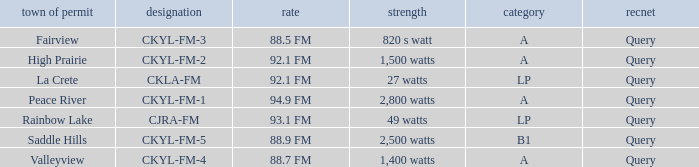Write the full table. {'header': ['town of permit', 'designation', 'rate', 'strength', 'category', 'recnet'], 'rows': [['Fairview', 'CKYL-FM-3', '88.5 FM', '820 s watt', 'A', 'Query'], ['High Prairie', 'CKYL-FM-2', '92.1 FM', '1,500 watts', 'A', 'Query'], ['La Crete', 'CKLA-FM', '92.1 FM', '27 watts', 'LP', 'Query'], ['Peace River', 'CKYL-FM-1', '94.9 FM', '2,800 watts', 'A', 'Query'], ['Rainbow Lake', 'CJRA-FM', '93.1 FM', '49 watts', 'LP', 'Query'], ['Saddle Hills', 'CKYL-FM-5', '88.9 FM', '2,500 watts', 'B1', 'Query'], ['Valleyview', 'CKYL-FM-4', '88.7 FM', '1,400 watts', 'A', 'Query']]} What is the frequency that has a fairview city of license 88.5 FM. 